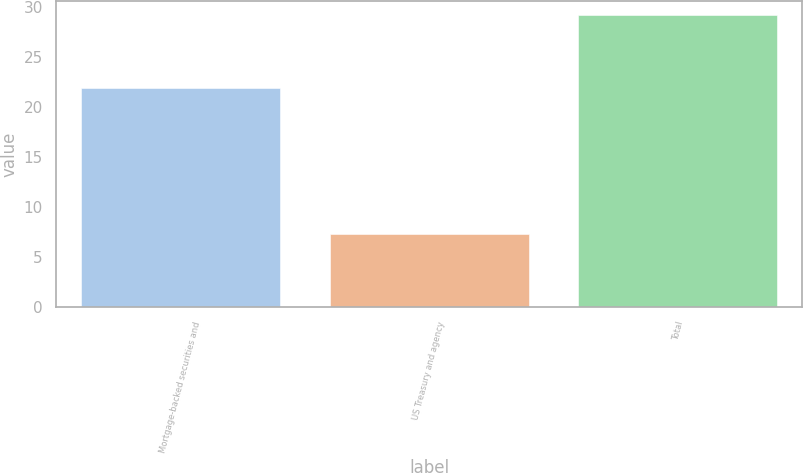Convert chart. <chart><loc_0><loc_0><loc_500><loc_500><bar_chart><fcel>Mortgage-backed securities and<fcel>US Treasury and agency<fcel>Total<nl><fcel>21.9<fcel>7.3<fcel>29.2<nl></chart> 